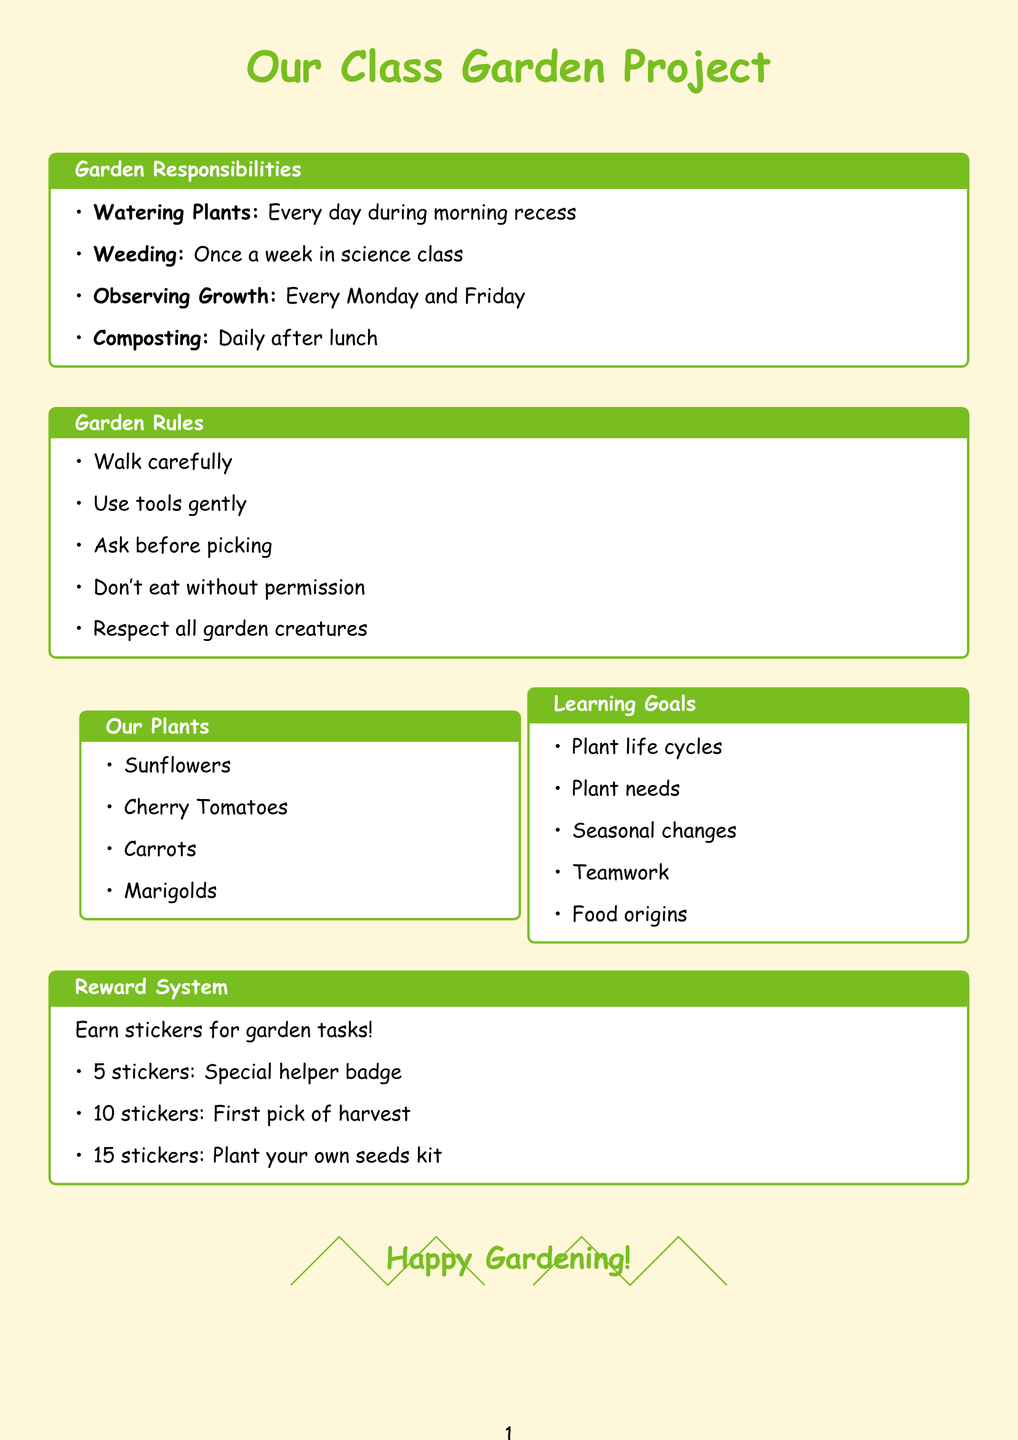What is the title of the garden responsibility that involves daily tasks? The title "Watering Plants" refers to the daily task responsibility listed in the document.
Answer: Watering Plants How often do we need to weed the garden? The document states that weeding is scheduled for once a week during science class.
Answer: Once a week What should you use to record plant growth? The document mentions that a garden journal is used for observing and recording growth.
Answer: Garden journal What is one of the fun facts about carrots? The document states that carrots were originally purple, not orange as a fun fact.
Answer: Carrots were originally purple What can students earn for completing garden tasks? The document mentions that students can earn stickers for completing various garden tasks.
Answer: Stickers How many stickers do you need to plant your own seeds at home kit? The document specifies that 15 stickers are needed to earn the plant your own seeds at home kit.
Answer: 15 stickers Why is it important to walk carefully in the garden? The document states that it is a rule to walk carefully to maintain safety in the garden area.
Answer: To maintain safety What type of plant needs support to climb? The document mentions that cherry tomatoes require support to climb as they grow.
Answer: Cherry Tomatoes What is one goal of the class garden project? The document lists understanding the life cycle of plants as one of the learning goals.
Answer: Understand the life cycle of plants 